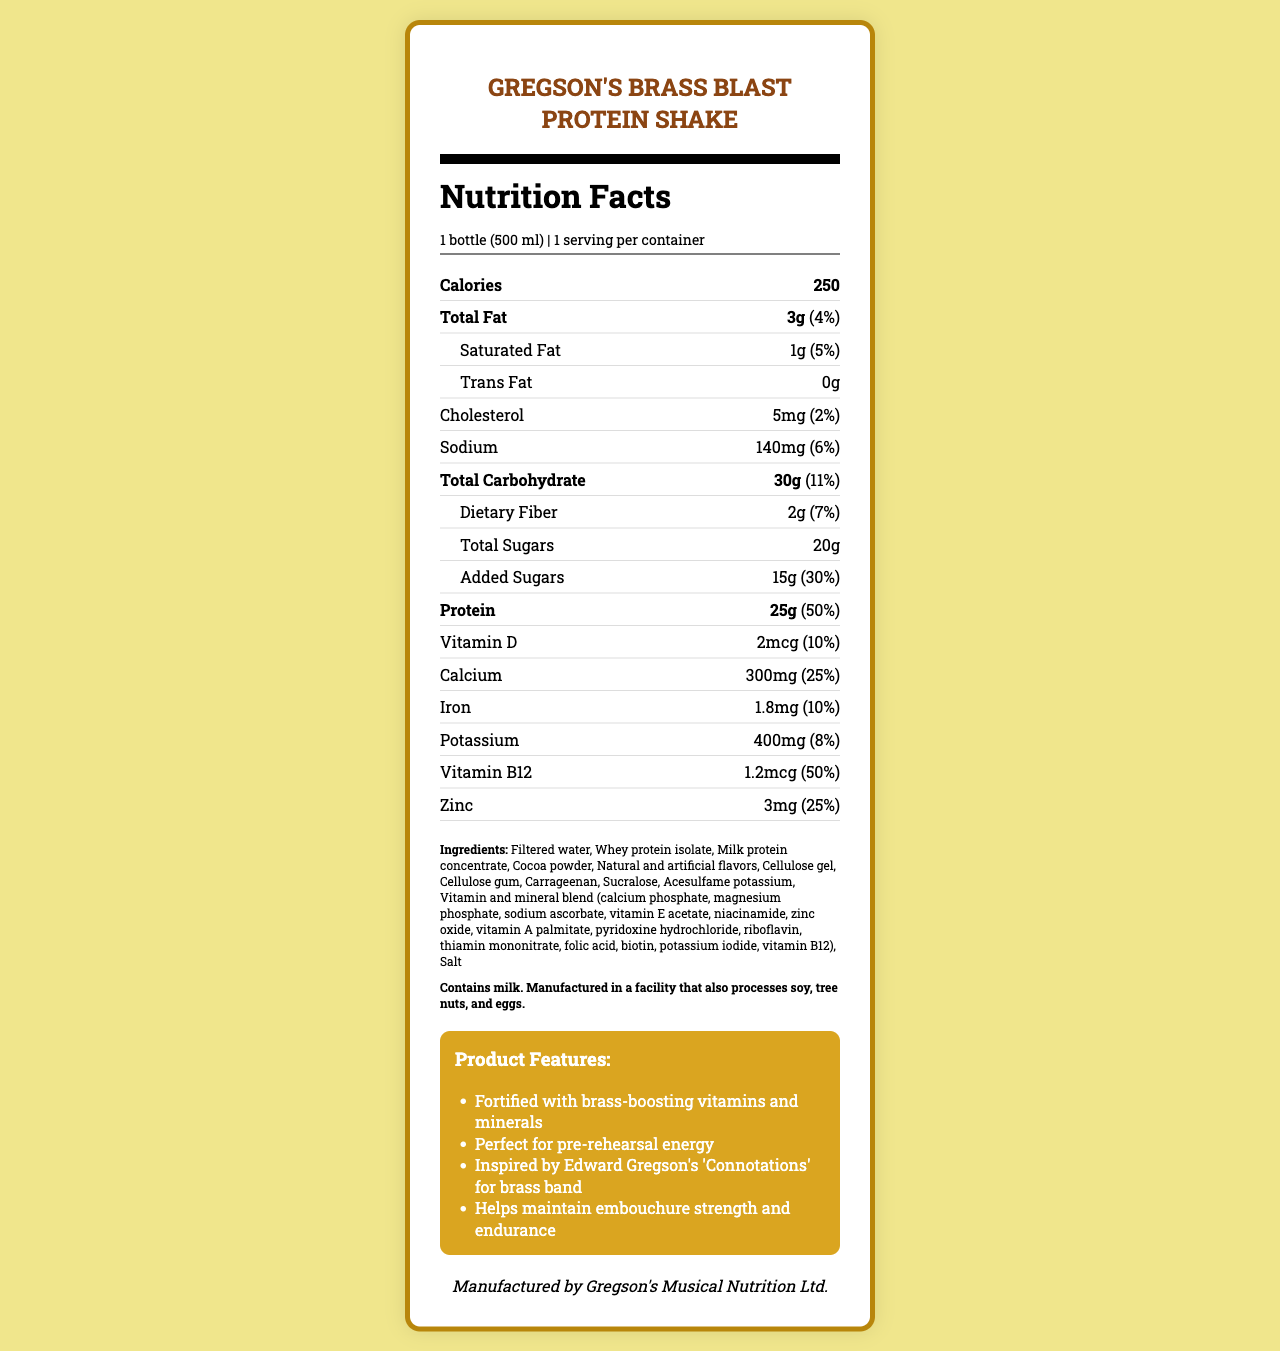what is the serving size for Gregson's Brass Blast Protein Shake? The serving size is explicitly stated as "1 bottle (500 ml)" in the document.
Answer: 1 bottle (500 ml) How many calories are in one serving of this protein shake? The document lists the calories per serving as 250.
Answer: 250 What is the amount of protein in one serving, and what percentage of the daily value does it represent? The document states that one serving contains 25g of protein, which is 50% of the daily value.
Answer: 25g, 50% List two ingredients present in Gregson's Brass Blast Protein Shake. The document lists several ingredients, including "Filtered water" and "Whey protein isolate."
Answer: Examples: Filtered water, Whey protein isolate What is the amount of total sugars in one serving of the shake? The document specifies that total sugars in one serving are 20g.
Answer: 20g How much calcium is in one serving, and what percentage of the daily value does it provide? The amount of calcium per serving is listed as 300mg, and it provides 25% of the daily value.
Answer: 300mg, 25% What are the added sugars content and its daily value percentage? A) 10g, 20% B) 15g, 25% C) 15g, 30% D) 20g, 35% The document mentions that added sugars are 15g, which represent 30% of the daily value.
Answer: C) 15g, 30% Which of the following minerals are NOT present in Gregson's Brass Blast Protein Shake? I) Zinc II) Iron III) Magnesium IV) Potassium The document lists zinc, iron, and potassium contents, but magnesium is not mentioned.
Answer: III) Magnesium Is Gregson's Brass Blast Protein Shake suitable for someone with lactose intolerance? The document includes allergen information indicating that the shake contains milk.
Answer: No Summarize the main purpose of Gregson's Brass Blast Protein Shake. The document describes the product as a protein shake designed to fuel brass musicians with energy and nutrients for rehearsals and performances, emphasizing its vitamin and mineral content.
Answer: To provide energy and nutrients for brass musicians during long rehearsals and performances. What genre of music is Edward Gregson known for? The document does not provide any information about Edward Gregson's genre of music.
Answer: I don't know 